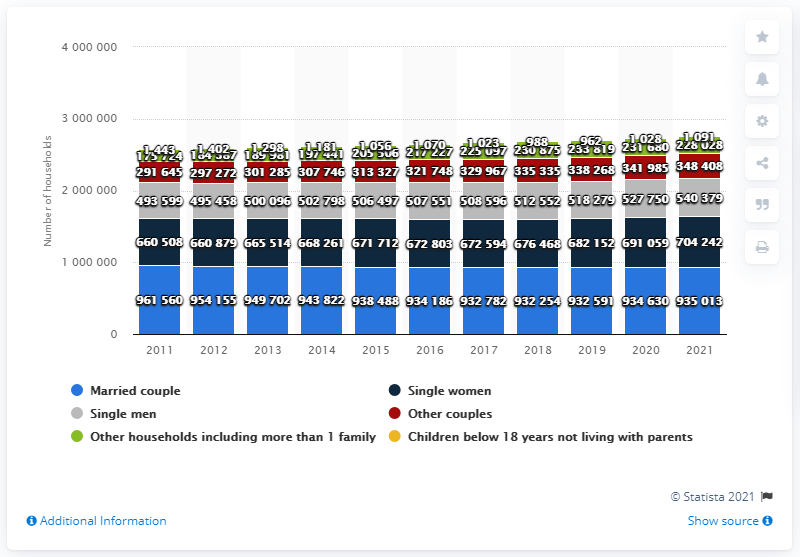Draw attention to some important aspects in this diagram. The number of households in Denmark peaked in 2021. In 2021, there were 935,013 married couple households in Denmark. 